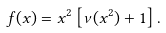Convert formula to latex. <formula><loc_0><loc_0><loc_500><loc_500>f ( x ) = x ^ { 2 } \left [ \nu ( x ^ { 2 } ) + 1 \right ] .</formula> 